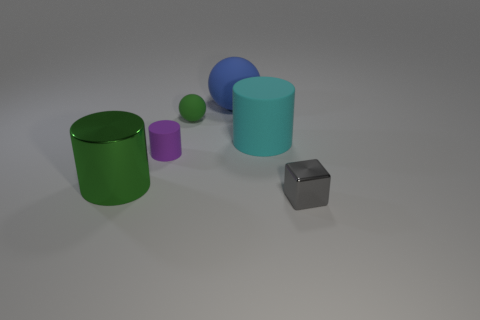Subtract all brown cubes. Subtract all brown balls. How many cubes are left? 1 Add 3 green shiny things. How many objects exist? 9 Subtract all cubes. How many objects are left? 5 Subtract all large yellow metal blocks. Subtract all gray metallic blocks. How many objects are left? 5 Add 4 large blue balls. How many large blue balls are left? 5 Add 1 red shiny cylinders. How many red shiny cylinders exist? 1 Subtract 1 gray cubes. How many objects are left? 5 